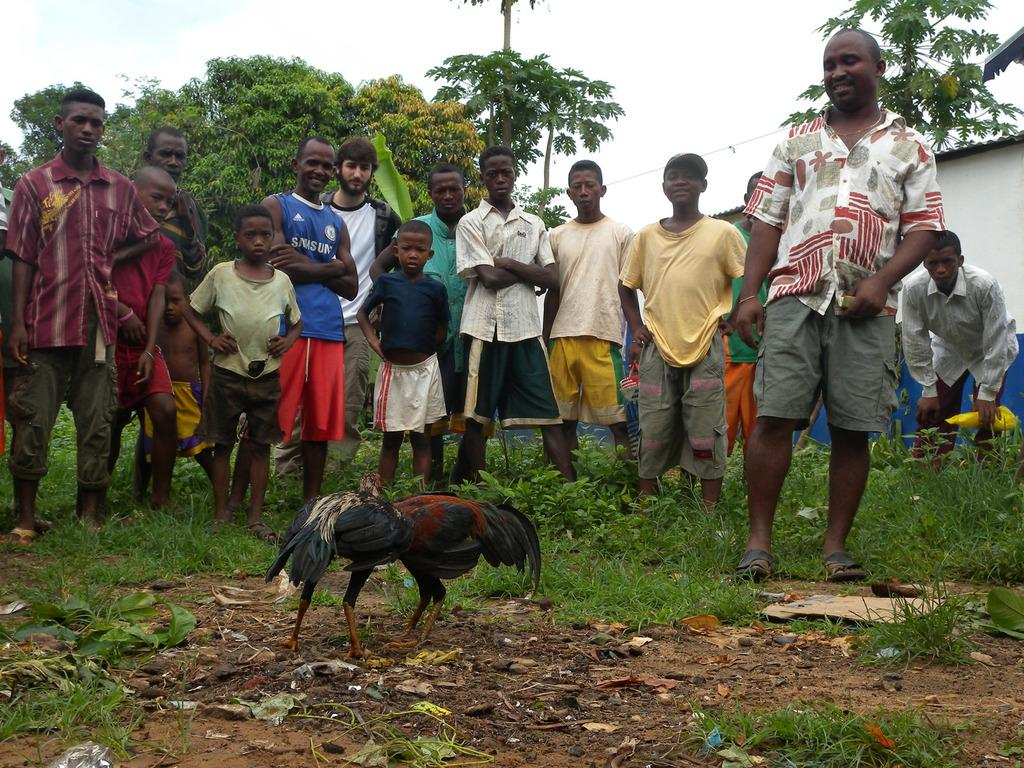How many people are present in the image? There are many people standing in the image. What animals can be seen in the image? There are two cocks in the image. What type of vegetation is on the ground in the image? There is grass on the ground in the image. What can be seen in the background of the image? There are trees and the sky visible in the background of the image. What structure is located on the right side of the image? There is a building on the right side of the image. What type of thunder can be heard in the image? There is no thunder present in the image; it is a still image with no sound. What type of pest is visible in the image? There is no pest visible in the image; the image features people, cocks, grass, trees, the sky, and a building. 